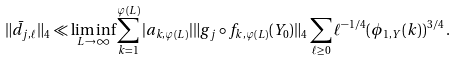Convert formula to latex. <formula><loc_0><loc_0><loc_500><loc_500>\| \bar { d } _ { j , \ell } \| _ { 4 } \ll \liminf _ { L \rightarrow \infty } \sum _ { k = 1 } ^ { \varphi ( L ) } | a _ { k , \varphi ( L ) } | \| g _ { j } \circ f _ { k , \varphi ( L ) } ( Y _ { 0 } ) \| _ { 4 } \sum _ { \ell \geq 0 } \ell ^ { - 1 / 4 } ( \phi _ { 1 , { Y } } ( k ) ) ^ { 3 / 4 } \, .</formula> 